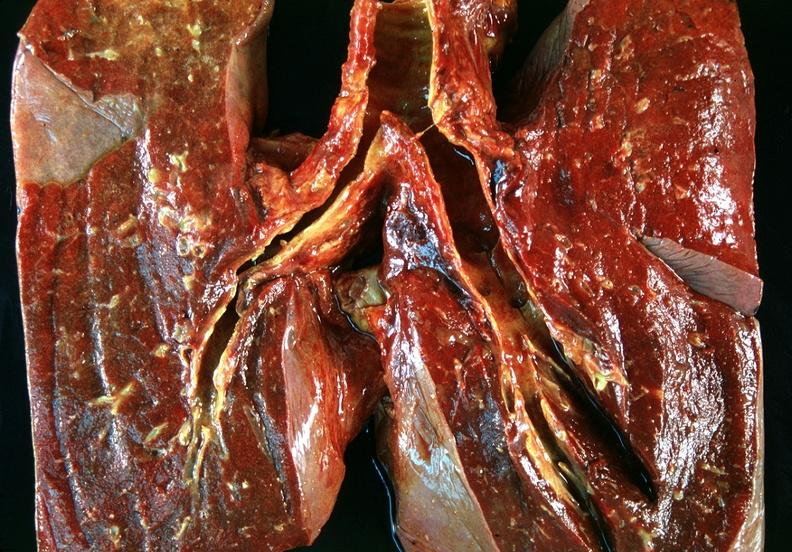s this myoma present?
Answer the question using a single word or phrase. No 